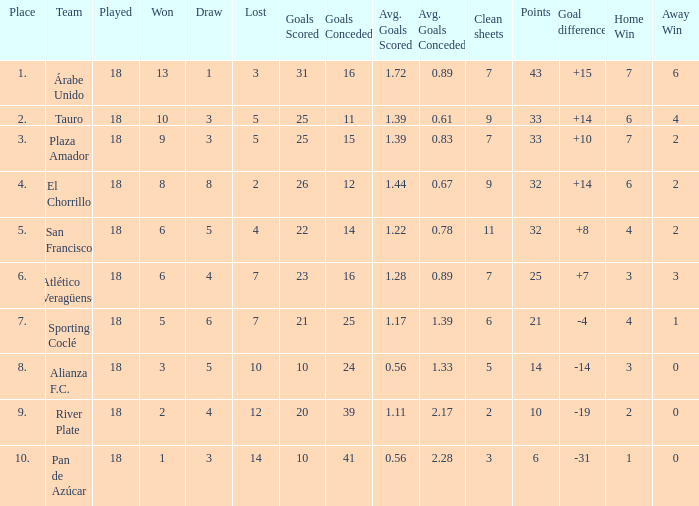How many goals were conceded by the team with more than 21 points more than 5 draws and less than 18 games played? None. 